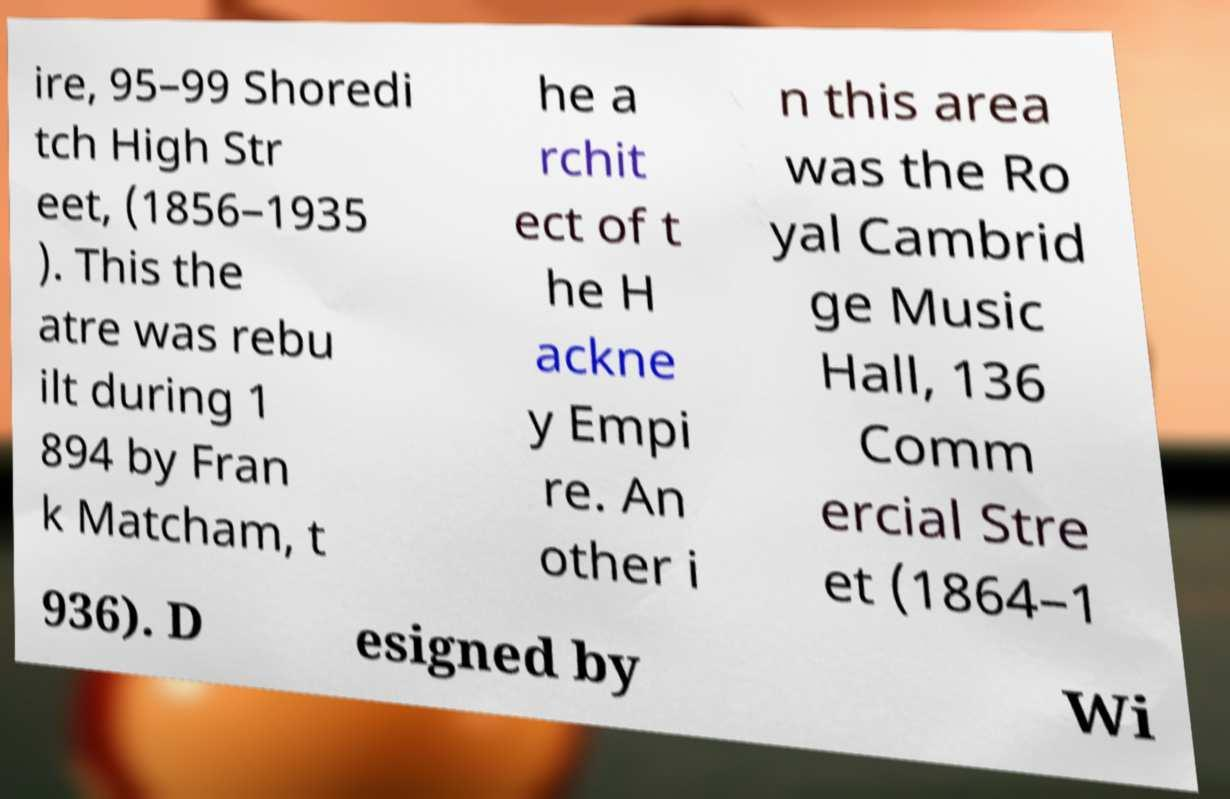Could you extract and type out the text from this image? ire, 95–99 Shoredi tch High Str eet, (1856–1935 ). This the atre was rebu ilt during 1 894 by Fran k Matcham, t he a rchit ect of t he H ackne y Empi re. An other i n this area was the Ro yal Cambrid ge Music Hall, 136 Comm ercial Stre et (1864–1 936). D esigned by Wi 